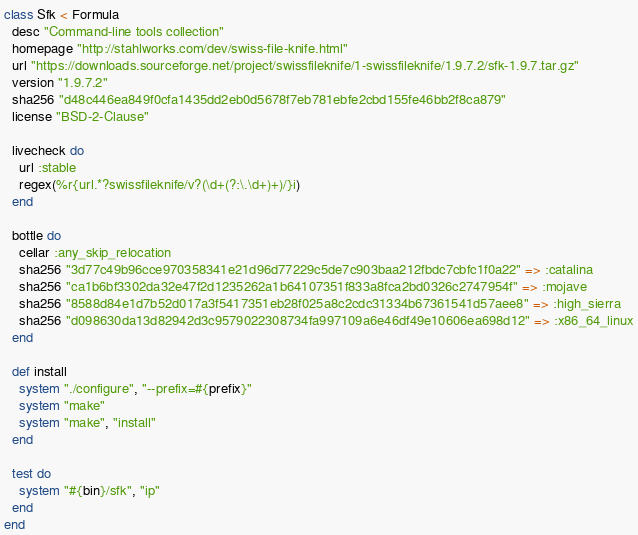<code> <loc_0><loc_0><loc_500><loc_500><_Ruby_>class Sfk < Formula
  desc "Command-line tools collection"
  homepage "http://stahlworks.com/dev/swiss-file-knife.html"
  url "https://downloads.sourceforge.net/project/swissfileknife/1-swissfileknife/1.9.7.2/sfk-1.9.7.tar.gz"
  version "1.9.7.2"
  sha256 "d48c446ea849f0cfa1435dd2eb0d5678f7eb781ebfe2cbd155fe46bb2f8ca879"
  license "BSD-2-Clause"

  livecheck do
    url :stable
    regex(%r{url.*?swissfileknife/v?(\d+(?:\.\d+)+)/}i)
  end

  bottle do
    cellar :any_skip_relocation
    sha256 "3d77c49b96cce970358341e21d96d77229c5de7c903baa212fbdc7cbfc1f0a22" => :catalina
    sha256 "ca1b6bf3302da32e47f2d1235262a1b64107351f833a8fca2bd0326c2747954f" => :mojave
    sha256 "8588d84e1d7b52d017a3f5417351eb28f025a8c2cdc31334b67361541d57aee8" => :high_sierra
    sha256 "d098630da13d82942d3c9579022308734fa997109a6e46df49e10606ea698d12" => :x86_64_linux
  end

  def install
    system "./configure", "--prefix=#{prefix}"
    system "make"
    system "make", "install"
  end

  test do
    system "#{bin}/sfk", "ip"
  end
end
</code> 